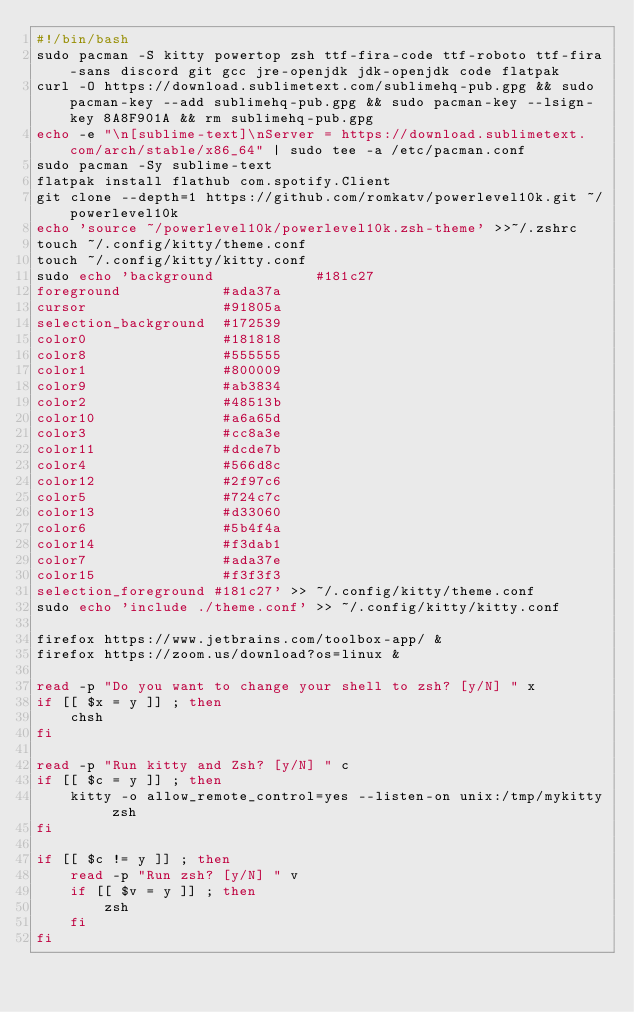Convert code to text. <code><loc_0><loc_0><loc_500><loc_500><_Bash_>#!/bin/bash
sudo pacman -S kitty powertop zsh ttf-fira-code ttf-roboto ttf-fira-sans discord git gcc jre-openjdk jdk-openjdk code flatpak
curl -O https://download.sublimetext.com/sublimehq-pub.gpg && sudo pacman-key --add sublimehq-pub.gpg && sudo pacman-key --lsign-key 8A8F901A && rm sublimehq-pub.gpg
echo -e "\n[sublime-text]\nServer = https://download.sublimetext.com/arch/stable/x86_64" | sudo tee -a /etc/pacman.conf
sudo pacman -Sy sublime-text
flatpak install flathub com.spotify.Client
git clone --depth=1 https://github.com/romkatv/powerlevel10k.git ~/powerlevel10k
echo 'source ~/powerlevel10k/powerlevel10k.zsh-theme' >>~/.zshrc
touch ~/.config/kitty/theme.conf
touch ~/.config/kitty/kitty.conf
sudo echo 'background            #181c27
foreground            #ada37a
cursor                #91805a
selection_background  #172539
color0                #181818
color8                #555555
color1                #800009
color9                #ab3834
color2                #48513b
color10               #a6a65d
color3                #cc8a3e
color11               #dcde7b
color4                #566d8c
color12               #2f97c6
color5                #724c7c
color13               #d33060
color6                #5b4f4a
color14               #f3dab1
color7                #ada37e
color15               #f3f3f3
selection_foreground #181c27' >> ~/.config/kitty/theme.conf
sudo echo 'include ./theme.conf' >> ~/.config/kitty/kitty.conf

firefox https://www.jetbrains.com/toolbox-app/ &
firefox https://zoom.us/download?os=linux &

read -p "Do you want to change your shell to zsh? [y/N] " x
if [[ $x = y ]] ; then
    chsh
fi

read -p "Run kitty and Zsh? [y/N] " c
if [[ $c = y ]] ; then
    kitty -o allow_remote_control=yes --listen-on unix:/tmp/mykitty zsh
fi

if [[ $c != y ]] ; then
    read -p "Run zsh? [y/N] " v
    if [[ $v = y ]] ; then
        zsh
    fi
fi
</code> 